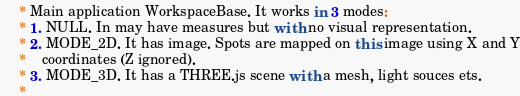<code> <loc_0><loc_0><loc_500><loc_500><_JavaScript_>     * Main application WorkspaceBase. It works in 3 modes:
     * 1. NULL. In may have measures but with no visual representation.
     * 2. MODE_2D. It has image. Spots are mapped on this image using X and Y
     *    coordinates (Z ignored).
     * 3. MODE_3D. It has a THREE.js scene with a mesh, light souces ets.
     *</code> 